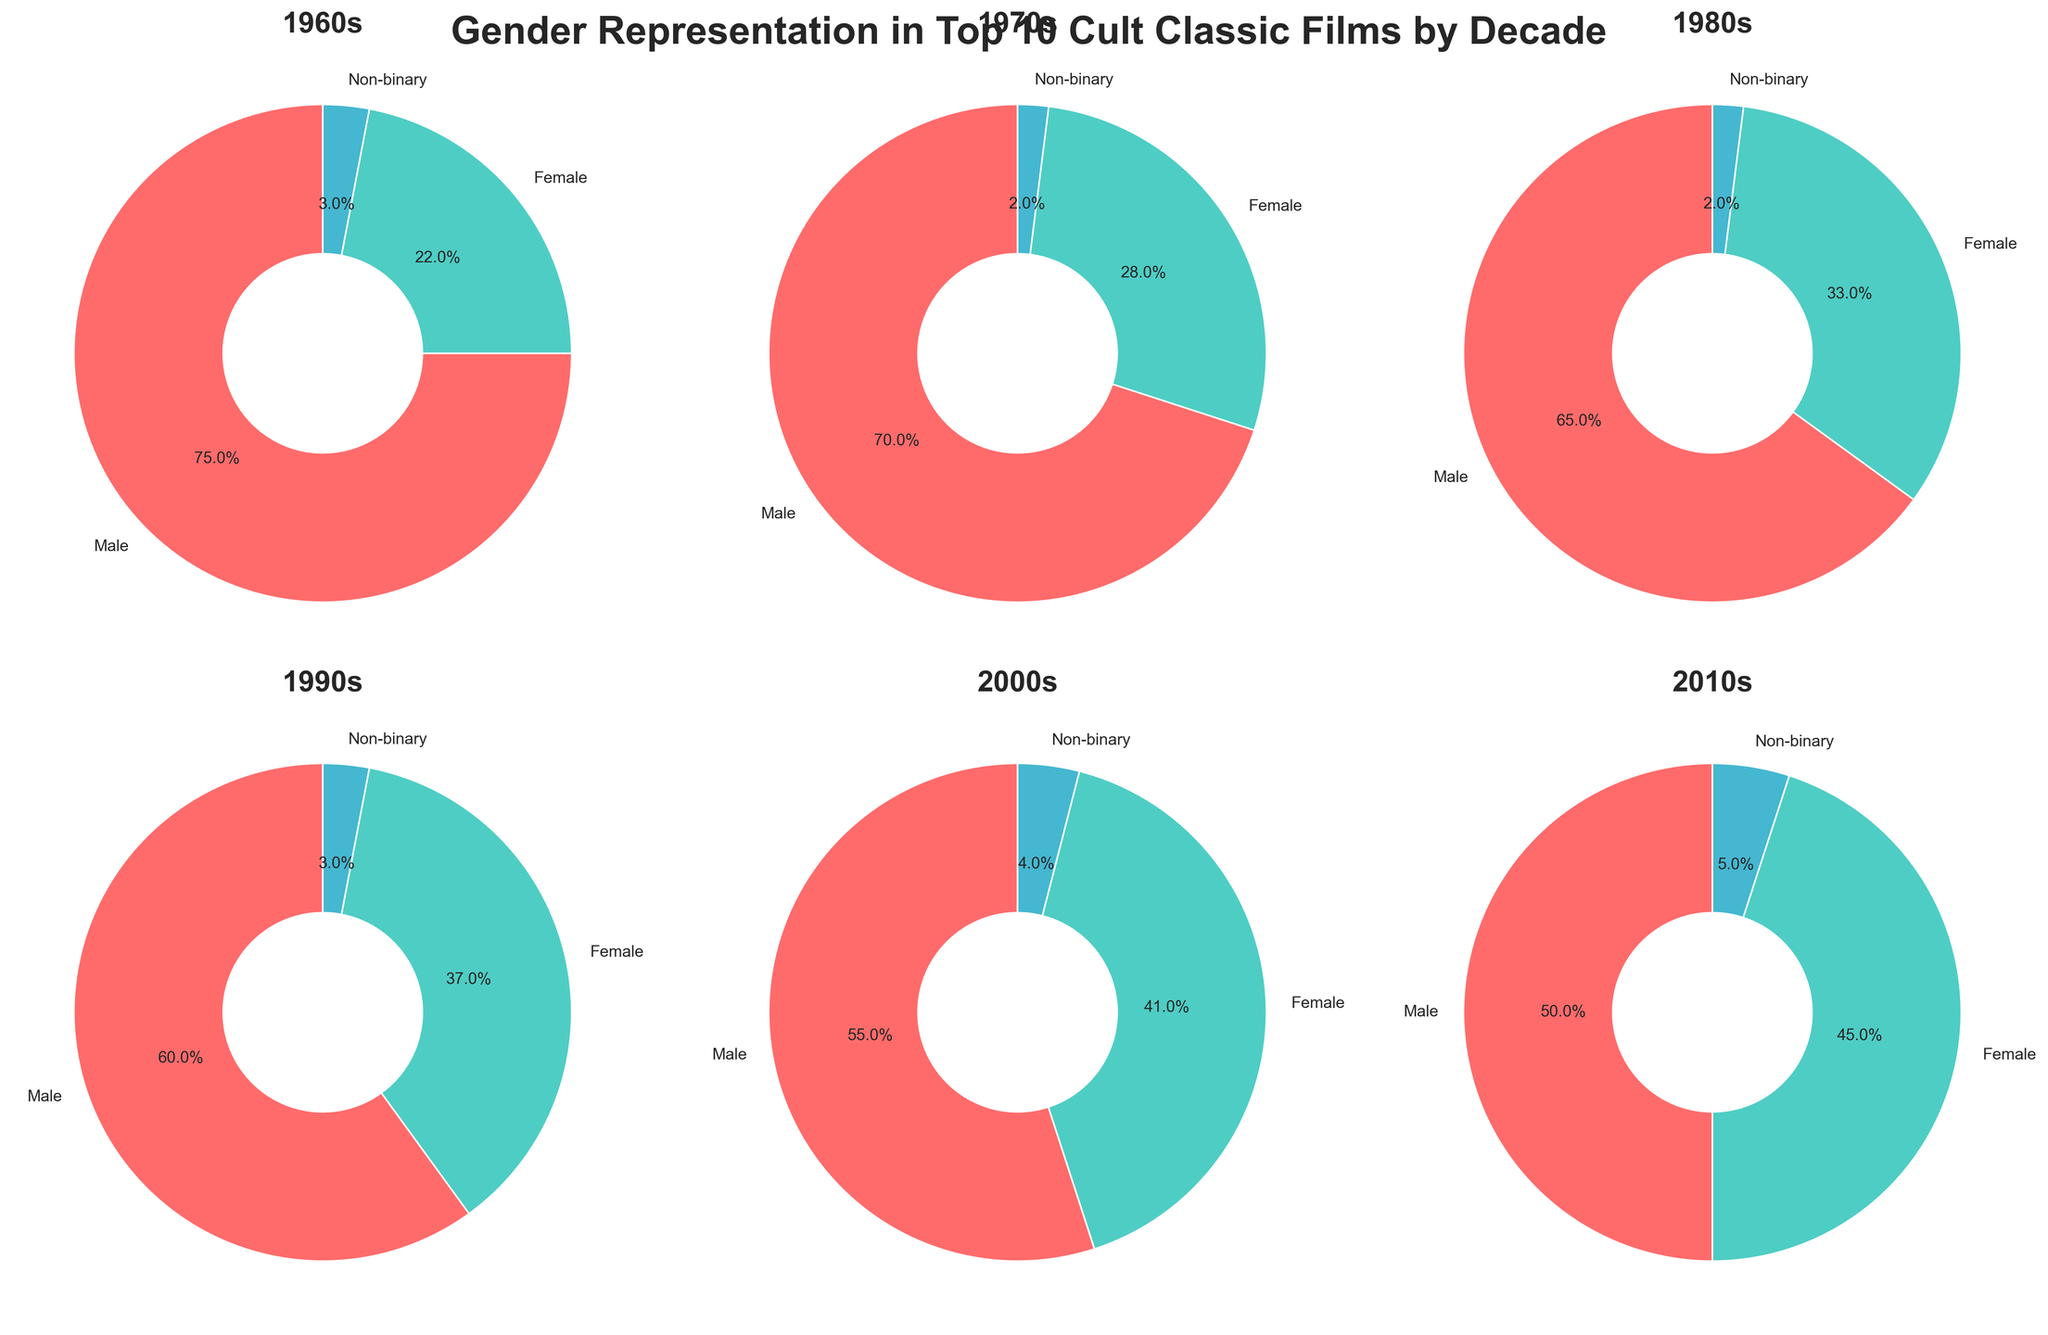What's the male gender representation in the 1980s? Look at the pie chart labeled "1980s". The slice representing male gender has a percentage labeled on it.
Answer: 65% Which decade shows a higher representation of females: 2000s or 2010s? Compare the pie charts labeled "2000s" and "2010s". The female representation in the 2000s is 41%, while in the 2010s it is 45%.
Answer: 2010s How did the representation of non-binary characters change from the 1960s to the 2010s? Look at the non-binary percentages across the decades. In the 1960s, it is 3%, and in the 2010s, it is 5%. The percentage increased by 2%.
Answer: Increased by 2% What's the average percentage of female representation in the 1970s, 1980s, and 1990s? The female percentages are 28% in the 1970s, 33% in the 1980s, and 37% in the 1990s. Sum these values and divide by 3: (28 + 33 + 37) / 3 = 32.67.
Answer: 32.67% Which decade has the least representation of non-binary characters? Look at all pie charts and compare the non-binary percentages. 1970s and 1980s both have the lowest percentage of 2%.
Answer: 1970s, 1980s What decade had the largest male representation? Review all pie charts for the highest male percentage. The 1960s had the largest male representation at 75%.
Answer: 1960s By how much did the female representation increase from the 1960s to the 2000s? Female representation in the 1960s was 22% and in the 2000s, it was 41%. The increase is 41% - 22% = 19%.
Answer: Increased by 19% Which decade shows the closest representation between male and female characters? Compare the difference between male and female percentages for each decade. The 2010s show the closest representation with 50% male and 45% female, a 5% difference.
Answer: 2010s 